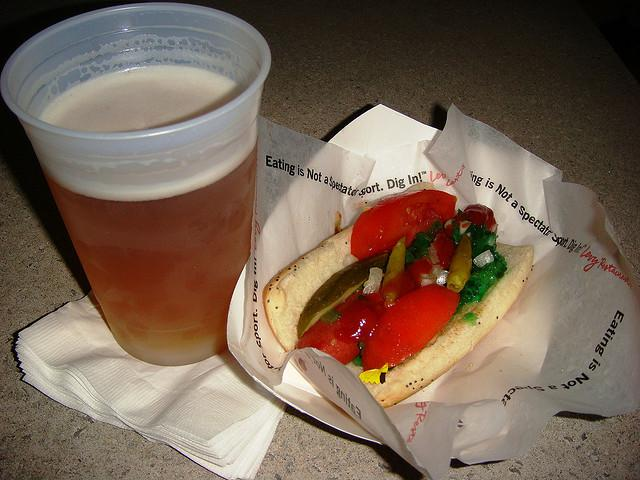What celebrity has a first name that is the same name as the red item in this tomato free sandwich? pepper adams 